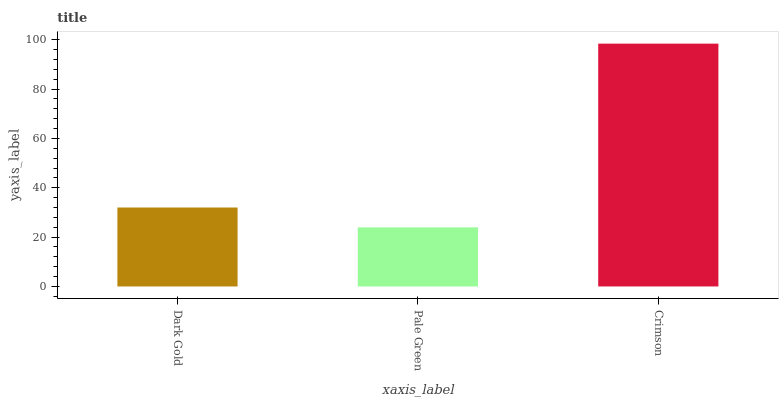Is Pale Green the minimum?
Answer yes or no. Yes. Is Crimson the maximum?
Answer yes or no. Yes. Is Crimson the minimum?
Answer yes or no. No. Is Pale Green the maximum?
Answer yes or no. No. Is Crimson greater than Pale Green?
Answer yes or no. Yes. Is Pale Green less than Crimson?
Answer yes or no. Yes. Is Pale Green greater than Crimson?
Answer yes or no. No. Is Crimson less than Pale Green?
Answer yes or no. No. Is Dark Gold the high median?
Answer yes or no. Yes. Is Dark Gold the low median?
Answer yes or no. Yes. Is Pale Green the high median?
Answer yes or no. No. Is Crimson the low median?
Answer yes or no. No. 